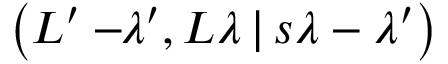<formula> <loc_0><loc_0><loc_500><loc_500>\left ( L ^ { \prime } - \, \lambda ^ { \prime } , L \lambda \, | \, s \lambda - \lambda ^ { \prime } \right )</formula> 